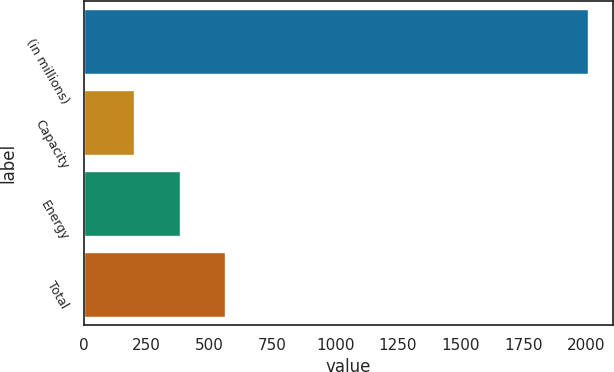Convert chart to OTSL. <chart><loc_0><loc_0><loc_500><loc_500><bar_chart><fcel>(in millions)<fcel>Capacity<fcel>Energy<fcel>Total<nl><fcel>2005<fcel>201<fcel>381.4<fcel>561.8<nl></chart> 